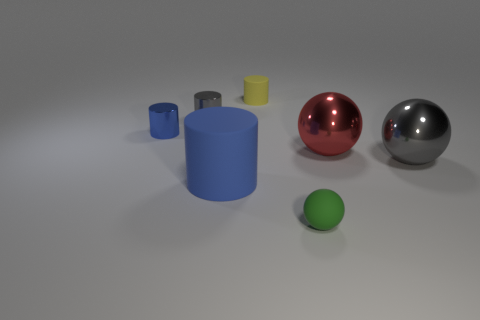The objects have different colors and shapes. Can you explain what they might represent or symbolize? The variety of shapes and colors could symbolize diversity and individuality. Cylinders and spheres might also represent different aspects of geometry, suggesting a theme around forms and dimensions. The colors could imply a playful or artistic element, invoking creativity and visual appeal. 